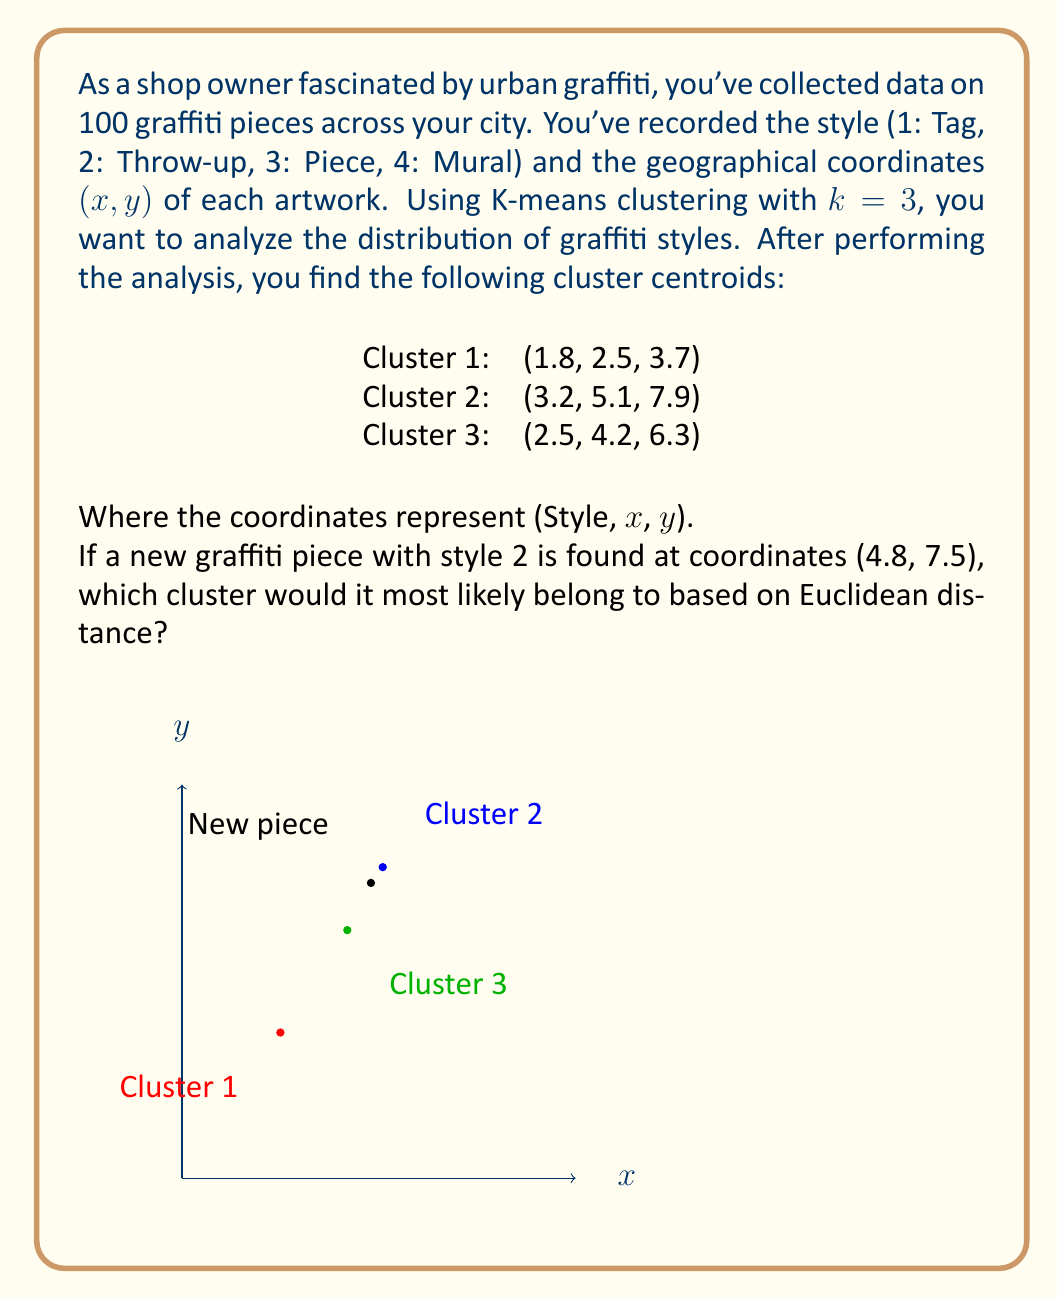Teach me how to tackle this problem. To determine which cluster the new graffiti piece belongs to, we need to calculate the Euclidean distance between the new piece and each cluster centroid, then choose the cluster with the shortest distance.

The Euclidean distance in 3D space is given by:

$$d = \sqrt{(x_2 - x_1)^2 + (y_2 - y_1)^2 + (z_2 - z_1)^2}$$

Let's calculate the distance to each cluster:

1. Distance to Cluster 1:
   $$d_1 = \sqrt{(2 - 1.8)^2 + (4.8 - 2.5)^2 + (7.5 - 3.7)^2}$$
   $$d_1 = \sqrt{0.04 + 5.29 + 14.44} = \sqrt{19.77} = 4.45$$

2. Distance to Cluster 2:
   $$d_2 = \sqrt{(2 - 3.2)^2 + (4.8 - 5.1)^2 + (7.5 - 7.9)^2}$$
   $$d_2 = \sqrt{1.44 + 0.09 + 0.16} = \sqrt{1.69} = 1.30$$

3. Distance to Cluster 3:
   $$d_3 = \sqrt{(2 - 2.5)^2 + (4.8 - 4.2)^2 + (7.5 - 6.3)^2}$$
   $$d_3 = \sqrt{0.25 + 0.36 + 1.44} = \sqrt{2.05} = 1.43$$

The shortest distance is $d_2 = 1.30$, corresponding to Cluster 2.
Answer: Cluster 2 